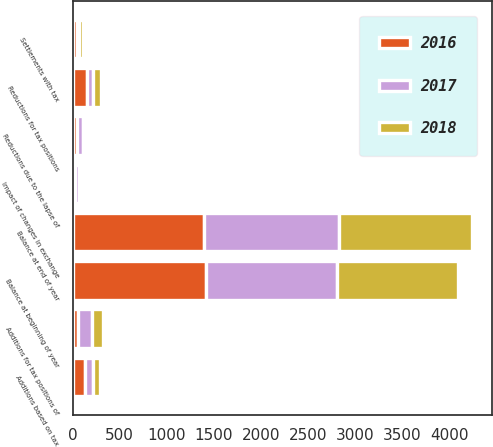Convert chart. <chart><loc_0><loc_0><loc_500><loc_500><stacked_bar_chart><ecel><fcel>Balance at beginning of year<fcel>Additions based on tax<fcel>Additions for tax positions of<fcel>Impact of changes in exchange<fcel>Settlements with tax<fcel>Reductions for tax positions<fcel>Reductions due to the lapse of<fcel>Balance at end of year<nl><fcel>2017<fcel>1393<fcel>88<fcel>145<fcel>41<fcel>22<fcel>57<fcel>73<fcel>1433<nl><fcel>2016<fcel>1419<fcel>132<fcel>58<fcel>23<fcel>41<fcel>157<fcel>41<fcel>1393<nl><fcel>2018<fcel>1285<fcel>70<fcel>119<fcel>25<fcel>45<fcel>85<fcel>27<fcel>1419<nl></chart> 